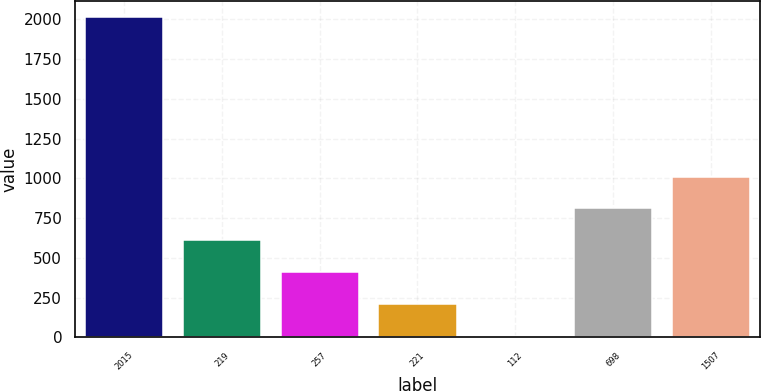<chart> <loc_0><loc_0><loc_500><loc_500><bar_chart><fcel>2015<fcel>219<fcel>257<fcel>221<fcel>112<fcel>698<fcel>1507<nl><fcel>2014<fcel>610.64<fcel>410.16<fcel>209.68<fcel>9.2<fcel>811.12<fcel>1011.6<nl></chart> 